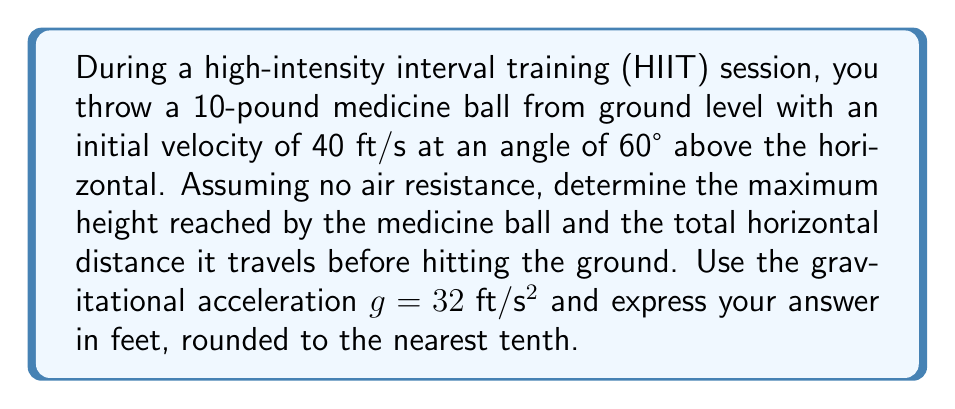Provide a solution to this math problem. Let's approach this step-by-step:

1) The trajectory of the medicine ball can be described by a parabolic equation. We'll use the parametric equations:

   $$x = v_0 \cos(\theta) \cdot t$$
   $$y = v_0 \sin(\theta) \cdot t - \frac{1}{2}gt^2$$

   Where $v_0$ is the initial velocity, $\theta$ is the launch angle, and $t$ is time.

2) Given information:
   $v_0 = 40 \text{ ft/s}$
   $\theta = 60°$
   $g = 32 \text{ ft}/\text{s}^2$

3) To find the maximum height, we need to determine when the vertical velocity is zero:

   $$v_y = v_0 \sin(\theta) - gt = 0$$
   $$t_{\text{max}} = \frac{v_0 \sin(\theta)}{g} = \frac{40 \sin(60°)}{32} = 1.08 \text{ s}$$

4) Substitute this time into the equation for $y$ to find the maximum height:

   $$y_{\text{max}} = v_0 \sin(\theta) \cdot t_{\text{max}} - \frac{1}{2}g{t_{\text{max}}}^2$$
   $$y_{\text{max}} = 40 \sin(60°) \cdot 1.08 - \frac{1}{2} \cdot 32 \cdot {1.08}^2 = 37.7 \text{ ft}$$

5) For the total horizontal distance, we need to find the time when the ball hits the ground (y = 0):

   $$0 = v_0 \sin(\theta) \cdot t - \frac{1}{2}gt^2$$

   Solving this quadratic equation:

   $$t_{\text{total}} = \frac{2v_0 \sin(\theta)}{g} = \frac{2 \cdot 40 \sin(60°)}{32} = 2.16 \text{ s}$$

6) Now substitute this time into the equation for $x$:

   $$x_{\text{total}} = v_0 \cos(\theta) \cdot t_{\text{total}}$$
   $$x_{\text{total}} = 40 \cos(60°) \cdot 2.16 = 43.2 \text{ ft}$$
Answer: Maximum height: 37.7 ft; Total horizontal distance: 43.2 ft 